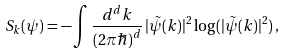Convert formula to latex. <formula><loc_0><loc_0><loc_500><loc_500>S _ { k } ( \psi ) = - \int \frac { d ^ { d } k } { ( 2 \pi \hbar { ) } ^ { d } } \, | \tilde { \psi } ( k ) | ^ { 2 } \log ( | \tilde { \psi } ( k ) | ^ { 2 } ) \, ,</formula> 